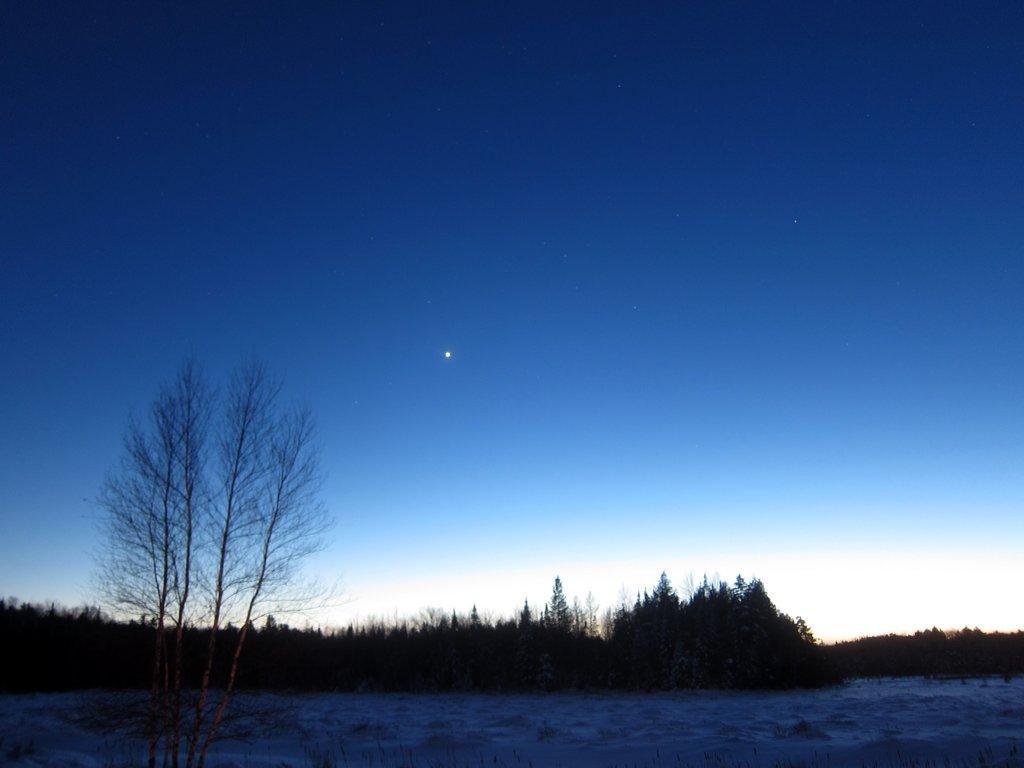What type of tree is in the front of the image? There is a dry tree in the front of the image. What can be seen in the background of the image? There are trees in the background of the image. What type of furniture is visible in the image? There is no furniture visible in the image; it primarily features trees. 